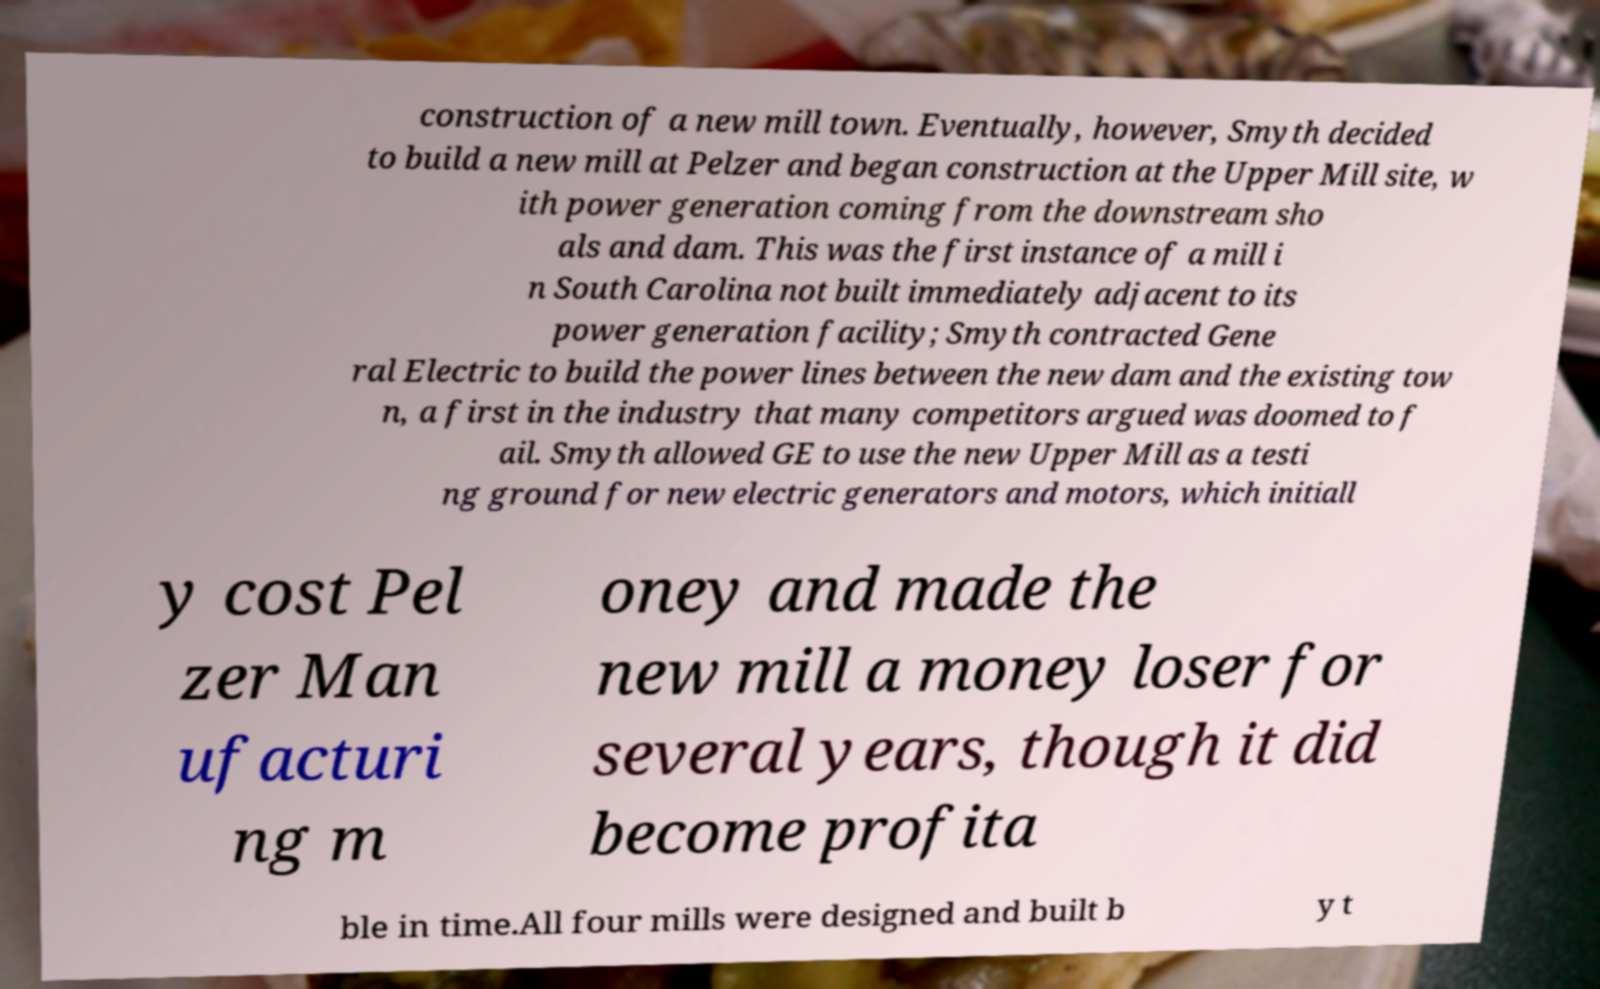I need the written content from this picture converted into text. Can you do that? construction of a new mill town. Eventually, however, Smyth decided to build a new mill at Pelzer and began construction at the Upper Mill site, w ith power generation coming from the downstream sho als and dam. This was the first instance of a mill i n South Carolina not built immediately adjacent to its power generation facility; Smyth contracted Gene ral Electric to build the power lines between the new dam and the existing tow n, a first in the industry that many competitors argued was doomed to f ail. Smyth allowed GE to use the new Upper Mill as a testi ng ground for new electric generators and motors, which initiall y cost Pel zer Man ufacturi ng m oney and made the new mill a money loser for several years, though it did become profita ble in time.All four mills were designed and built b y t 